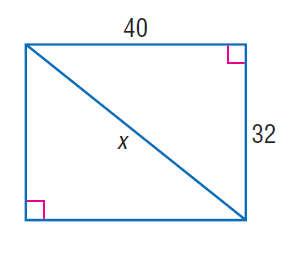Answer the mathemtical geometry problem and directly provide the correct option letter.
Question: Find x.
Choices: A: 24 B: 32 C: 40 D: 8 \sqrt { 41 } D 